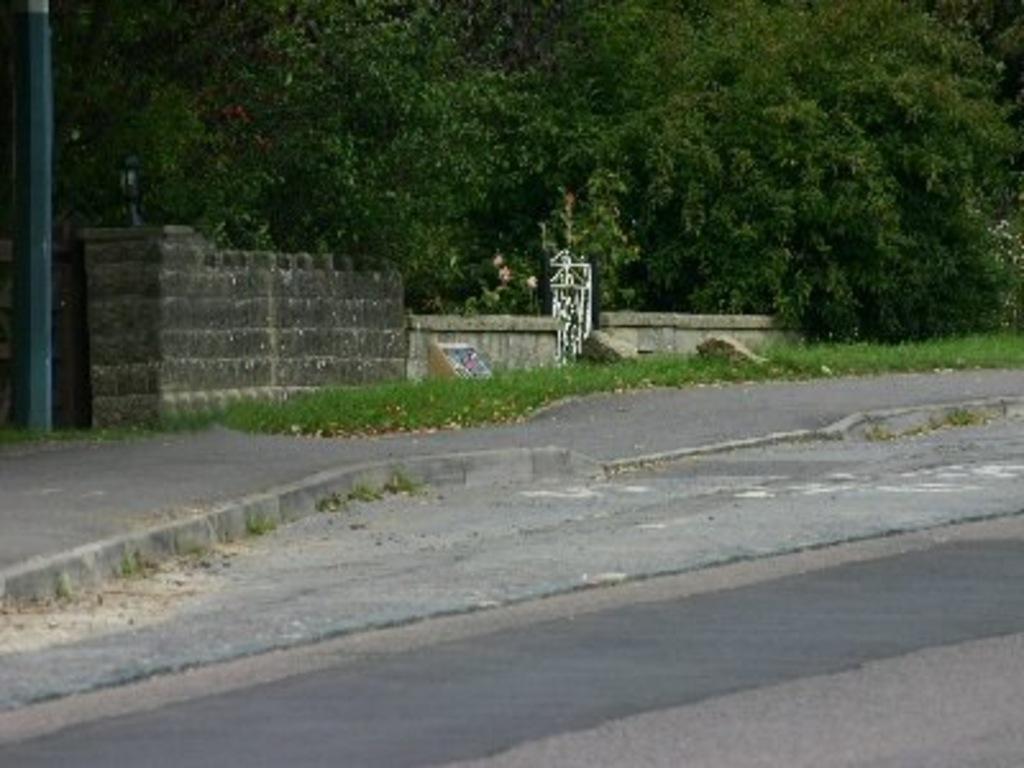How would you summarize this image in a sentence or two? In this image we can see a road. There are many trees in the image. There is a grassy land in the image. There are two gates in the image. There is a fencing in the image. There is a pole in the image. 